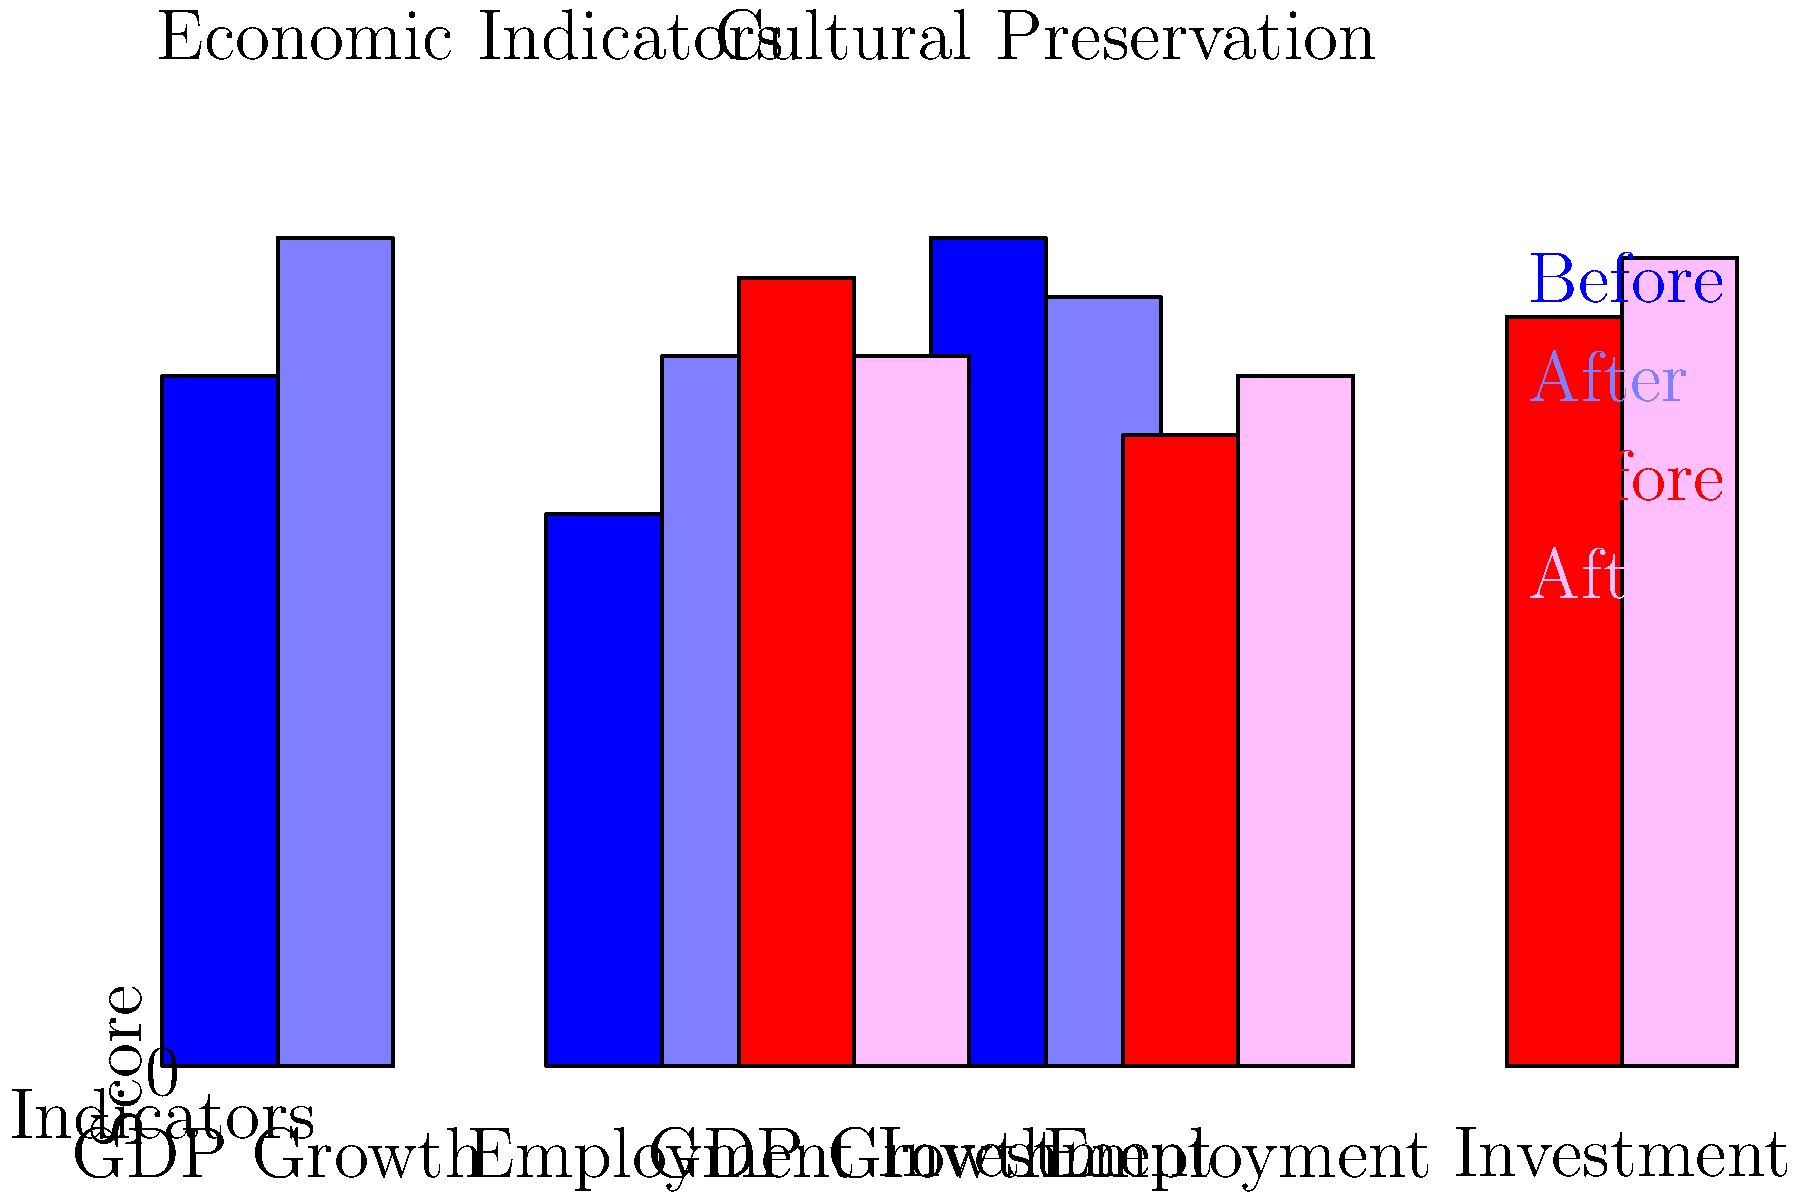Based on the bar charts showing economic indicators and cultural preservation metrics before and after policy changes, which area shows the most significant overall improvement, and what potential trade-off does this suggest? To answer this question, we need to analyze the changes in both economic indicators and cultural preservation metrics:

1. Economic Indicators:
   a. GDP Growth: Increased from 3.5 to 4.2 (+0.7)
   b. Employment: Increased from 2.8 to 3.6 (+0.8)
   c. Investment: Decreased from 4.2 to 3.9 (-0.3)
   Overall change: +1.2 (sum of changes)

2. Cultural Preservation Metrics:
   a. Indicator 1: Decreased from 4.0 to 3.6 (-0.4)
   b. Indicator 2: Increased from 3.2 to 3.5 (+0.3)
   c. Indicator 3: Increased from 3.8 to 4.1 (+0.3)
   Overall change: +0.2 (sum of changes)

3. Comparing the overall changes:
   Economic Indicators: +1.2
   Cultural Preservation: +0.2

4. The economic indicators show a more significant overall improvement (+1.2) compared to cultural preservation metrics (+0.2).

5. This suggests a potential trade-off between economic development and cultural preservation. While the economy has seen more substantial growth, cultural preservation has improved only slightly, indicating that the policy changes may have prioritized economic growth over cultural aspects.
Answer: Economic indicators show greater improvement, suggesting a trade-off favoring economic growth over cultural preservation. 